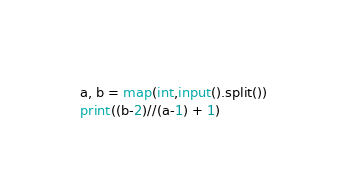Convert code to text. <code><loc_0><loc_0><loc_500><loc_500><_Python_>a, b = map(int,input().split())
print((b-2)//(a-1) + 1)</code> 